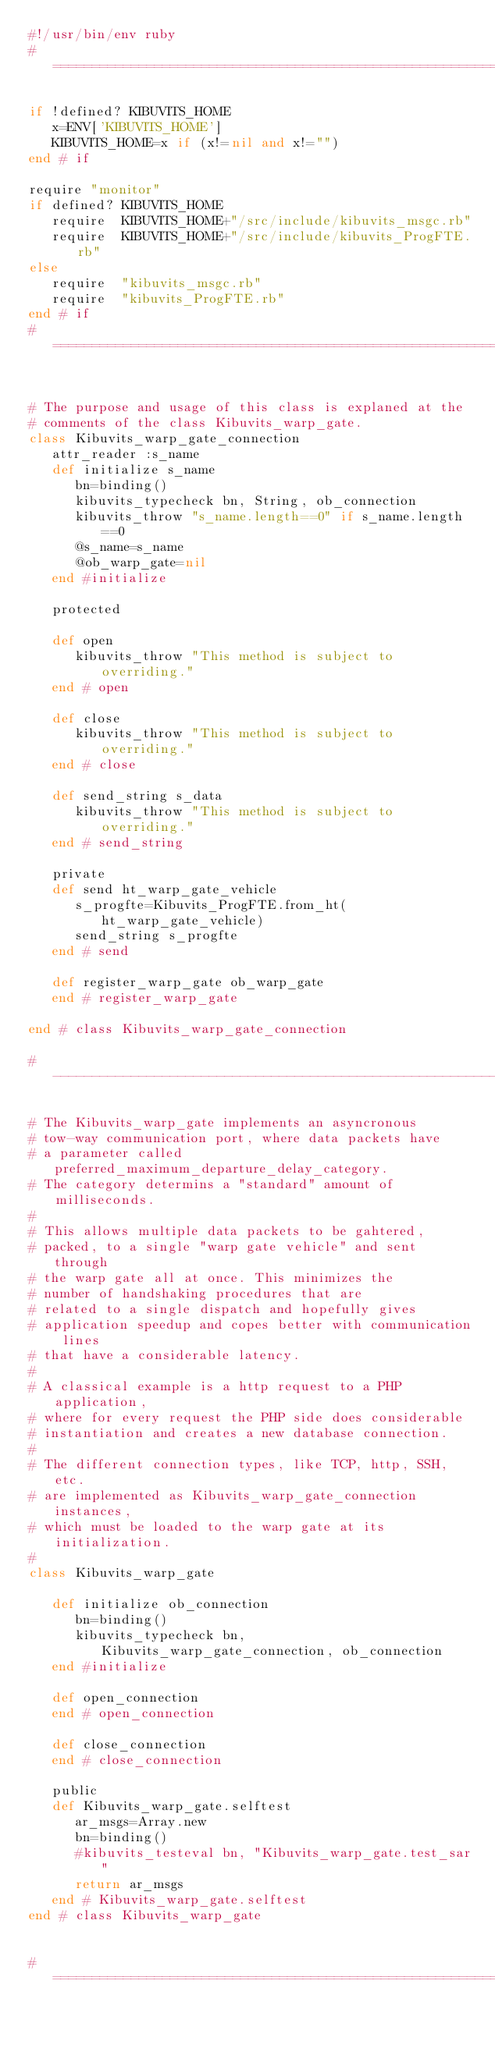Convert code to text. <code><loc_0><loc_0><loc_500><loc_500><_Ruby_>#!/usr/bin/env ruby
#=========================================================================

if !defined? KIBUVITS_HOME
   x=ENV['KIBUVITS_HOME']
   KIBUVITS_HOME=x if (x!=nil and x!="")
end # if

require "monitor"
if defined? KIBUVITS_HOME
   require  KIBUVITS_HOME+"/src/include/kibuvits_msgc.rb"
   require  KIBUVITS_HOME+"/src/include/kibuvits_ProgFTE.rb"
else
   require  "kibuvits_msgc.rb"
   require  "kibuvits_ProgFTE.rb"
end # if
#==========================================================================


# The purpose and usage of this class is explaned at the
# comments of the class Kibuvits_warp_gate.
class Kibuvits_warp_gate_connection
   attr_reader :s_name
   def initialize s_name
      bn=binding()
      kibuvits_typecheck bn, String, ob_connection
      kibuvits_throw "s_name.length==0" if s_name.length==0
      @s_name=s_name
      @ob_warp_gate=nil
   end #initialize

   protected

   def open
      kibuvits_throw "This method is subject to overriding."
   end # open

   def close
      kibuvits_throw "This method is subject to overriding."
   end # close

   def send_string s_data
      kibuvits_throw "This method is subject to overriding."
   end # send_string

   private
   def send ht_warp_gate_vehicle
      s_progfte=Kibuvits_ProgFTE.from_ht(ht_warp_gate_vehicle)
      send_string s_progfte
   end # send

   def register_warp_gate ob_warp_gate
   end # register_warp_gate

end # class Kibuvits_warp_gate_connection

#---------------------------------------------------------------------------

# The Kibuvits_warp_gate implements an asyncronous
# tow-way communication port, where data packets have
# a parameter called preferred_maximum_departure_delay_category.
# The category determins a "standard" amount of milliseconds.
#
# This allows multiple data packets to be gahtered,
# packed, to a single "warp gate vehicle" and sent through
# the warp gate all at once. This minimizes the
# number of handshaking procedures that are
# related to a single dispatch and hopefully gives
# application speedup and copes better with communication lines
# that have a considerable latency.
#
# A classical example is a http request to a PHP application,
# where for every request the PHP side does considerable
# instantiation and creates a new database connection.
#
# The different connection types, like TCP, http, SSH, etc.
# are implemented as Kibuvits_warp_gate_connection instances,
# which must be loaded to the warp gate at its initialization.
#
class Kibuvits_warp_gate

   def initialize ob_connection
      bn=binding()
      kibuvits_typecheck bn, Kibuvits_warp_gate_connection, ob_connection
   end #initialize

   def open_connection
   end # open_connection

   def close_connection
   end # close_connection

   public
   def Kibuvits_warp_gate.selftest
      ar_msgs=Array.new
      bn=binding()
      #kibuvits_testeval bn, "Kibuvits_warp_gate.test_sar"
      return ar_msgs
   end # Kibuvits_warp_gate.selftest
end # class Kibuvits_warp_gate


#=========================================================================
</code> 